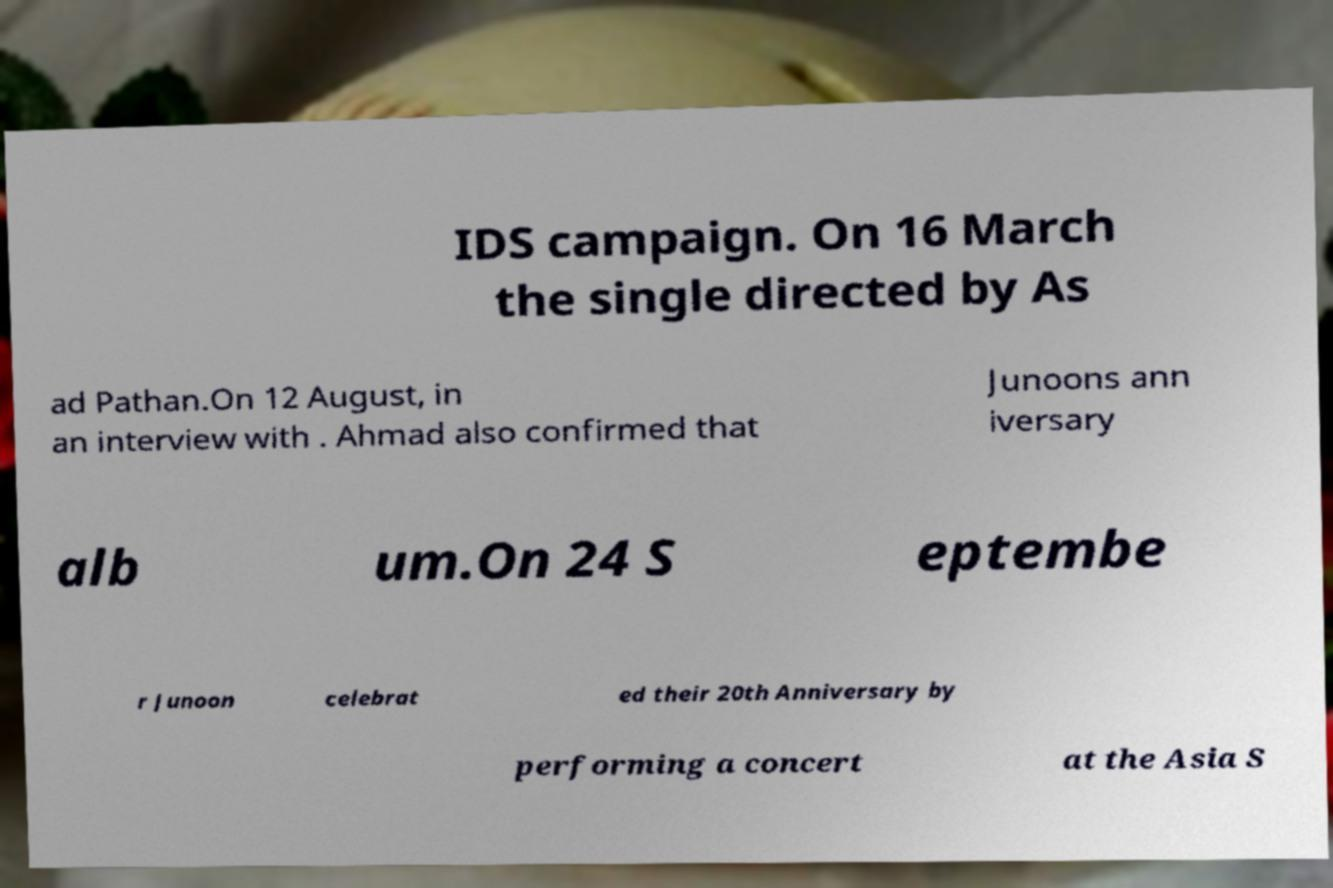Can you accurately transcribe the text from the provided image for me? IDS campaign. On 16 March the single directed by As ad Pathan.On 12 August, in an interview with . Ahmad also confirmed that Junoons ann iversary alb um.On 24 S eptembe r Junoon celebrat ed their 20th Anniversary by performing a concert at the Asia S 